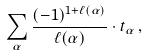Convert formula to latex. <formula><loc_0><loc_0><loc_500><loc_500>\sum _ { \alpha } { \frac { ( - 1 ) ^ { 1 + \ell ( \alpha ) } } { \ell ( \alpha ) } } \cdot t _ { \alpha } \, ,</formula> 